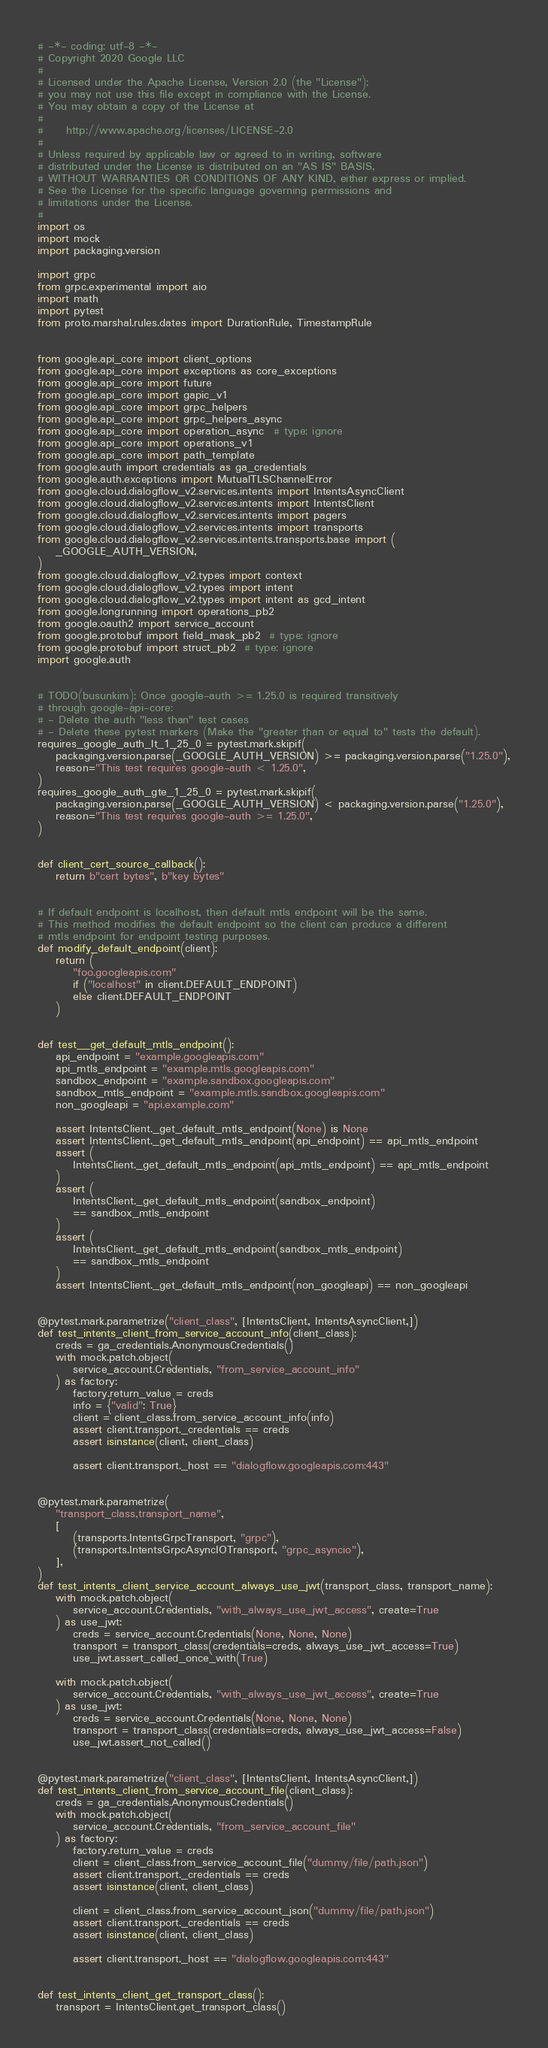Convert code to text. <code><loc_0><loc_0><loc_500><loc_500><_Python_># -*- coding: utf-8 -*-
# Copyright 2020 Google LLC
#
# Licensed under the Apache License, Version 2.0 (the "License");
# you may not use this file except in compliance with the License.
# You may obtain a copy of the License at
#
#     http://www.apache.org/licenses/LICENSE-2.0
#
# Unless required by applicable law or agreed to in writing, software
# distributed under the License is distributed on an "AS IS" BASIS,
# WITHOUT WARRANTIES OR CONDITIONS OF ANY KIND, either express or implied.
# See the License for the specific language governing permissions and
# limitations under the License.
#
import os
import mock
import packaging.version

import grpc
from grpc.experimental import aio
import math
import pytest
from proto.marshal.rules.dates import DurationRule, TimestampRule


from google.api_core import client_options
from google.api_core import exceptions as core_exceptions
from google.api_core import future
from google.api_core import gapic_v1
from google.api_core import grpc_helpers
from google.api_core import grpc_helpers_async
from google.api_core import operation_async  # type: ignore
from google.api_core import operations_v1
from google.api_core import path_template
from google.auth import credentials as ga_credentials
from google.auth.exceptions import MutualTLSChannelError
from google.cloud.dialogflow_v2.services.intents import IntentsAsyncClient
from google.cloud.dialogflow_v2.services.intents import IntentsClient
from google.cloud.dialogflow_v2.services.intents import pagers
from google.cloud.dialogflow_v2.services.intents import transports
from google.cloud.dialogflow_v2.services.intents.transports.base import (
    _GOOGLE_AUTH_VERSION,
)
from google.cloud.dialogflow_v2.types import context
from google.cloud.dialogflow_v2.types import intent
from google.cloud.dialogflow_v2.types import intent as gcd_intent
from google.longrunning import operations_pb2
from google.oauth2 import service_account
from google.protobuf import field_mask_pb2  # type: ignore
from google.protobuf import struct_pb2  # type: ignore
import google.auth


# TODO(busunkim): Once google-auth >= 1.25.0 is required transitively
# through google-api-core:
# - Delete the auth "less than" test cases
# - Delete these pytest markers (Make the "greater than or equal to" tests the default).
requires_google_auth_lt_1_25_0 = pytest.mark.skipif(
    packaging.version.parse(_GOOGLE_AUTH_VERSION) >= packaging.version.parse("1.25.0"),
    reason="This test requires google-auth < 1.25.0",
)
requires_google_auth_gte_1_25_0 = pytest.mark.skipif(
    packaging.version.parse(_GOOGLE_AUTH_VERSION) < packaging.version.parse("1.25.0"),
    reason="This test requires google-auth >= 1.25.0",
)


def client_cert_source_callback():
    return b"cert bytes", b"key bytes"


# If default endpoint is localhost, then default mtls endpoint will be the same.
# This method modifies the default endpoint so the client can produce a different
# mtls endpoint for endpoint testing purposes.
def modify_default_endpoint(client):
    return (
        "foo.googleapis.com"
        if ("localhost" in client.DEFAULT_ENDPOINT)
        else client.DEFAULT_ENDPOINT
    )


def test__get_default_mtls_endpoint():
    api_endpoint = "example.googleapis.com"
    api_mtls_endpoint = "example.mtls.googleapis.com"
    sandbox_endpoint = "example.sandbox.googleapis.com"
    sandbox_mtls_endpoint = "example.mtls.sandbox.googleapis.com"
    non_googleapi = "api.example.com"

    assert IntentsClient._get_default_mtls_endpoint(None) is None
    assert IntentsClient._get_default_mtls_endpoint(api_endpoint) == api_mtls_endpoint
    assert (
        IntentsClient._get_default_mtls_endpoint(api_mtls_endpoint) == api_mtls_endpoint
    )
    assert (
        IntentsClient._get_default_mtls_endpoint(sandbox_endpoint)
        == sandbox_mtls_endpoint
    )
    assert (
        IntentsClient._get_default_mtls_endpoint(sandbox_mtls_endpoint)
        == sandbox_mtls_endpoint
    )
    assert IntentsClient._get_default_mtls_endpoint(non_googleapi) == non_googleapi


@pytest.mark.parametrize("client_class", [IntentsClient, IntentsAsyncClient,])
def test_intents_client_from_service_account_info(client_class):
    creds = ga_credentials.AnonymousCredentials()
    with mock.patch.object(
        service_account.Credentials, "from_service_account_info"
    ) as factory:
        factory.return_value = creds
        info = {"valid": True}
        client = client_class.from_service_account_info(info)
        assert client.transport._credentials == creds
        assert isinstance(client, client_class)

        assert client.transport._host == "dialogflow.googleapis.com:443"


@pytest.mark.parametrize(
    "transport_class,transport_name",
    [
        (transports.IntentsGrpcTransport, "grpc"),
        (transports.IntentsGrpcAsyncIOTransport, "grpc_asyncio"),
    ],
)
def test_intents_client_service_account_always_use_jwt(transport_class, transport_name):
    with mock.patch.object(
        service_account.Credentials, "with_always_use_jwt_access", create=True
    ) as use_jwt:
        creds = service_account.Credentials(None, None, None)
        transport = transport_class(credentials=creds, always_use_jwt_access=True)
        use_jwt.assert_called_once_with(True)

    with mock.patch.object(
        service_account.Credentials, "with_always_use_jwt_access", create=True
    ) as use_jwt:
        creds = service_account.Credentials(None, None, None)
        transport = transport_class(credentials=creds, always_use_jwt_access=False)
        use_jwt.assert_not_called()


@pytest.mark.parametrize("client_class", [IntentsClient, IntentsAsyncClient,])
def test_intents_client_from_service_account_file(client_class):
    creds = ga_credentials.AnonymousCredentials()
    with mock.patch.object(
        service_account.Credentials, "from_service_account_file"
    ) as factory:
        factory.return_value = creds
        client = client_class.from_service_account_file("dummy/file/path.json")
        assert client.transport._credentials == creds
        assert isinstance(client, client_class)

        client = client_class.from_service_account_json("dummy/file/path.json")
        assert client.transport._credentials == creds
        assert isinstance(client, client_class)

        assert client.transport._host == "dialogflow.googleapis.com:443"


def test_intents_client_get_transport_class():
    transport = IntentsClient.get_transport_class()</code> 